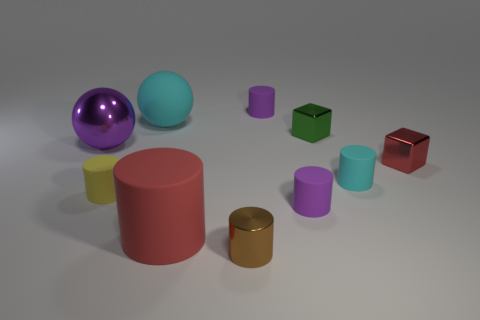Subtract all small yellow matte cylinders. How many cylinders are left? 5 Subtract 2 balls. How many balls are left? 0 Subtract all red blocks. How many blocks are left? 1 Subtract all cylinders. How many objects are left? 4 Subtract 1 brown cylinders. How many objects are left? 9 Subtract all red cylinders. Subtract all brown balls. How many cylinders are left? 5 Subtract all green cylinders. How many green cubes are left? 1 Subtract all small green blocks. Subtract all cyan matte objects. How many objects are left? 7 Add 4 small green objects. How many small green objects are left? 5 Add 1 tiny blue rubber cylinders. How many tiny blue rubber cylinders exist? 1 